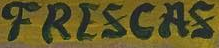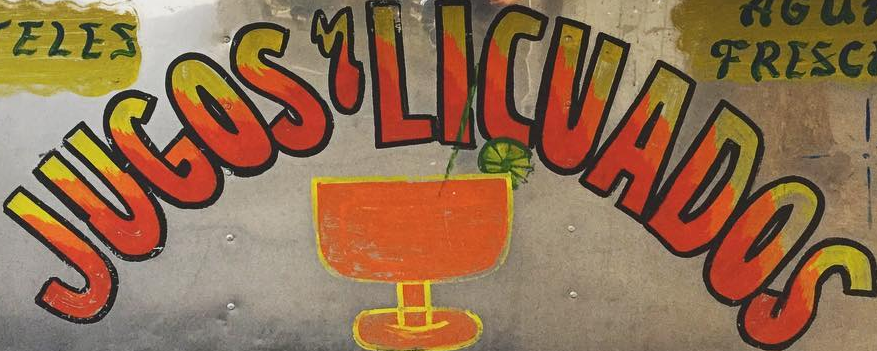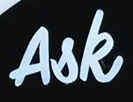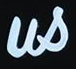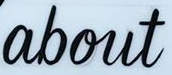What text appears in these images from left to right, separated by a semicolon? FRESCAS; JUGOS'LICUADOS; Ask; us; about 